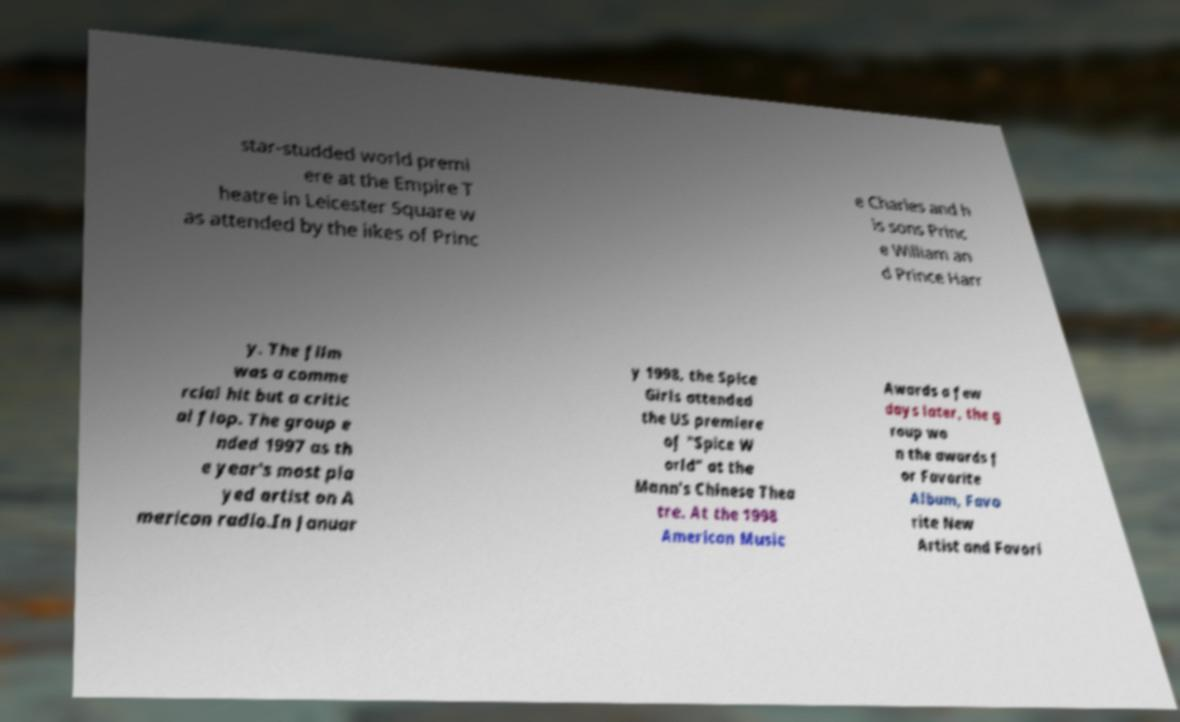Can you accurately transcribe the text from the provided image for me? star-studded world premi ere at the Empire T heatre in Leicester Square w as attended by the likes of Princ e Charles and h is sons Princ e William an d Prince Harr y. The film was a comme rcial hit but a critic al flop. The group e nded 1997 as th e year's most pla yed artist on A merican radio.In Januar y 1998, the Spice Girls attended the US premiere of "Spice W orld" at the Mann's Chinese Thea tre. At the 1998 American Music Awards a few days later, the g roup wo n the awards f or Favorite Album, Favo rite New Artist and Favori 